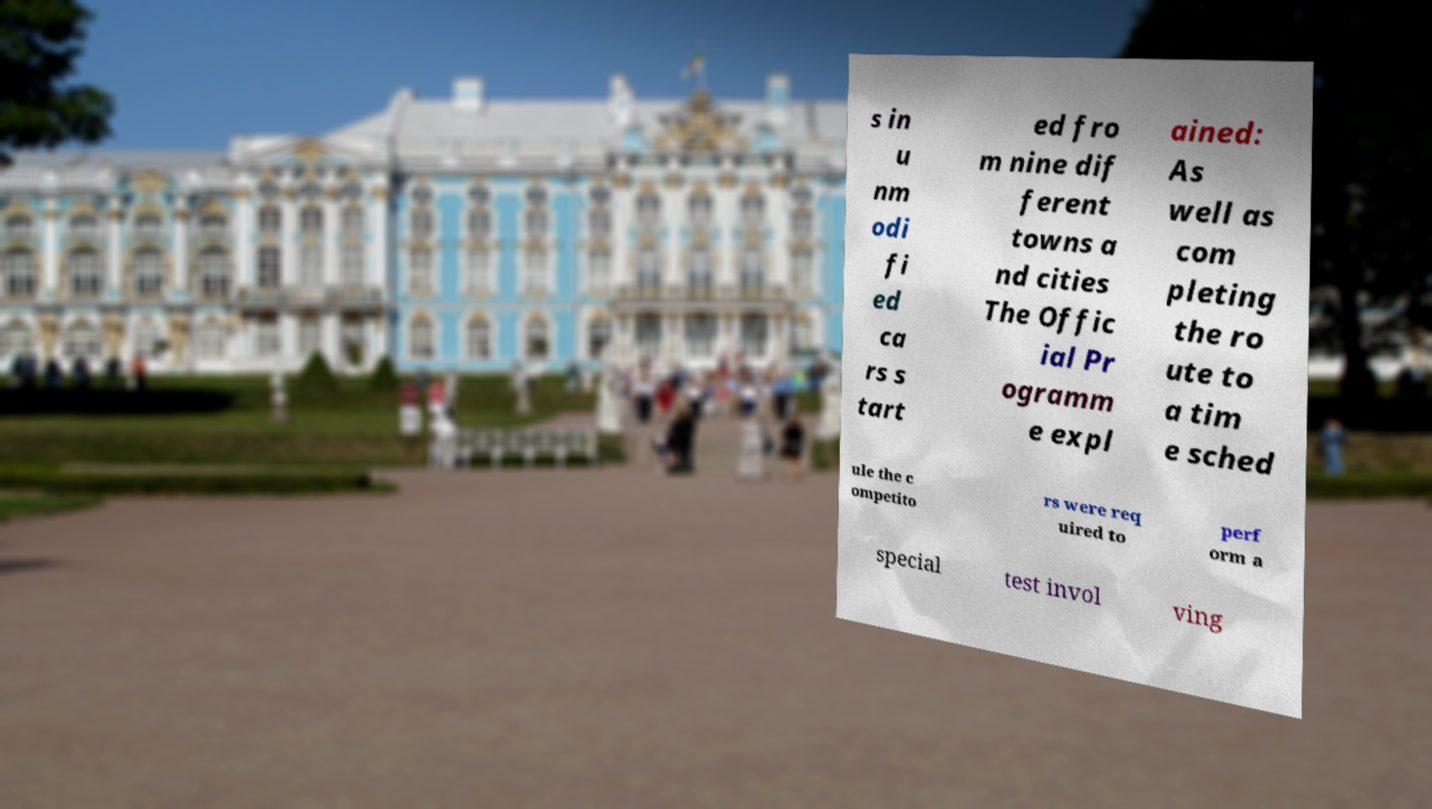What messages or text are displayed in this image? I need them in a readable, typed format. s in u nm odi fi ed ca rs s tart ed fro m nine dif ferent towns a nd cities The Offic ial Pr ogramm e expl ained: As well as com pleting the ro ute to a tim e sched ule the c ompetito rs were req uired to perf orm a special test invol ving 